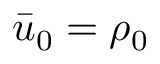Convert formula to latex. <formula><loc_0><loc_0><loc_500><loc_500>\bar { u } _ { 0 } = \rho _ { 0 }</formula> 